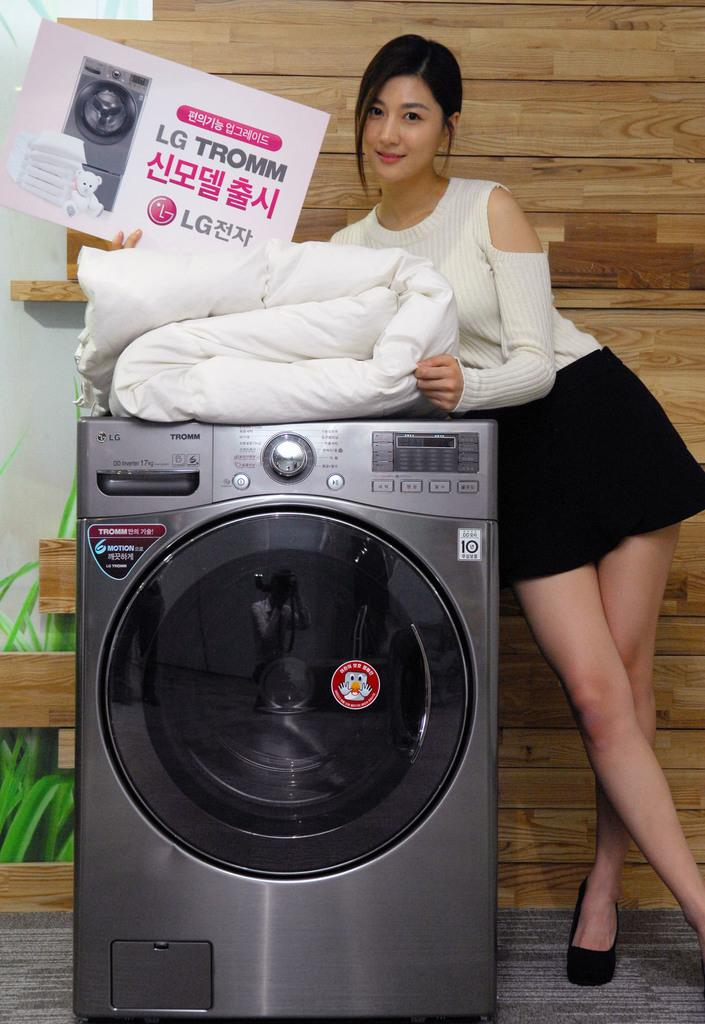What is the woman in the image doing? The woman is standing in the image and holding a board. What else can be seen in the image besides the woman? There is a bed sheet on a washing machine. What type of wall is visible in the background of the image? There is a wooden wall in the background of the image. What type of doctor is the woman in the image? There is no indication in the image that the woman is a doctor, so it cannot be determined from the picture. What part of the manager's job is being performed in the image? There is no manager present in the image, so it cannot be determined what part of their job is being performed. 